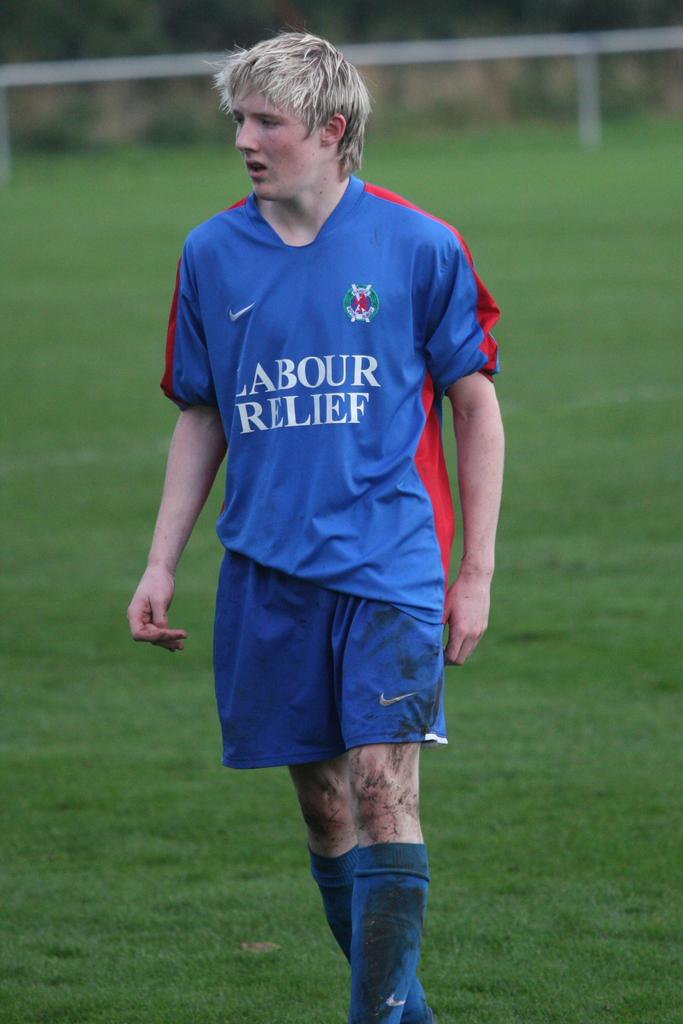Provide a one-sentence caption for the provided image. A dirty soccer player with a blue uniform and the words Labour Relief on the front. 